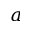<formula> <loc_0><loc_0><loc_500><loc_500>a</formula> 